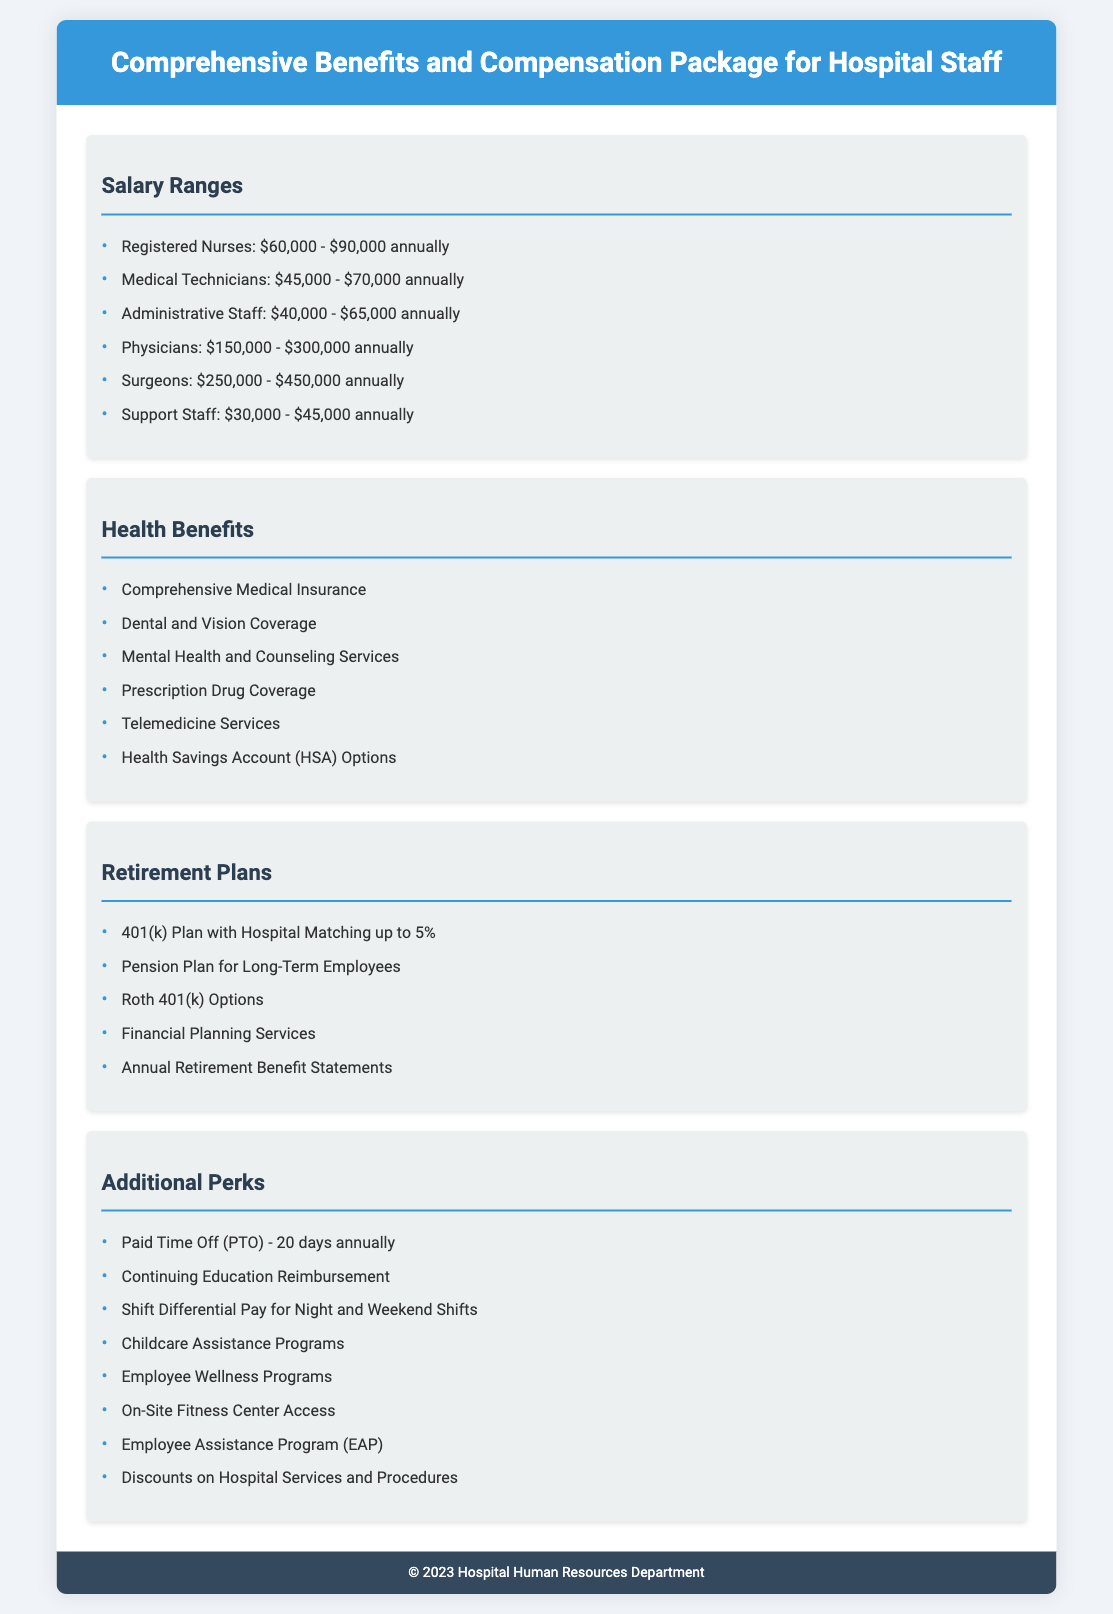What is the salary range for Registered Nurses? The salary range for Registered Nurses is specified in the document as $60,000 - $90,000 annually.
Answer: $60,000 - $90,000 annually What types of health benefits are offered? The document lists various health benefits, including comprehensive medical insurance and dental and vision coverage.
Answer: Comprehensive Medical Insurance, Dental and Vision Coverage What is the 401(k) plan matching percentage? The document specifies that the 401(k) plan includes hospital matching up to a certain percentage.
Answer: 5% How many days of Paid Time Off (PTO) are provided annually? The document specifies the amount of Paid Time Off offered to staff annually.
Answer: 20 days Which position has the highest salary range? The document lists various positions and their corresponding salary ranges, indicating which one has the highest.
Answer: Surgeons What additional perks are related to education reimbursement? The document mentions one of the additional perks related to continuing education for staff.
Answer: Continuing Education Reimbursement What is offered as part of the Employee Assistance Program (EAP)? The document refers to the Employee Assistance Program but does not specify the details of the services.
Answer: Employee Assistance Program What benefit is available for childcare? The document provides information on support related to childcare for hospital staff.
Answer: Childcare Assistance Programs What type of coverage is provided for mental health? The document lists mental health services among the health benefits.
Answer: Mental Health and Counseling Services 